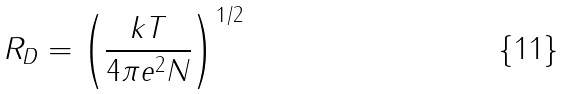<formula> <loc_0><loc_0><loc_500><loc_500>R _ { D } = \left ( \frac { k T } { 4 \pi e ^ { 2 } N } \right ) ^ { 1 / 2 }</formula> 